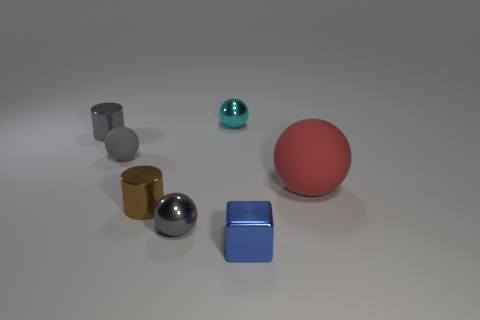Subtract all tiny spheres. How many spheres are left? 1 Subtract all cyan spheres. How many spheres are left? 3 Subtract all brown spheres. Subtract all green blocks. How many spheres are left? 4 Add 2 tiny metal cylinders. How many objects exist? 9 Subtract all blocks. How many objects are left? 6 Subtract 0 gray blocks. How many objects are left? 7 Subtract all big red cylinders. Subtract all tiny cyan balls. How many objects are left? 6 Add 6 gray shiny objects. How many gray shiny objects are left? 8 Add 7 tiny blue shiny objects. How many tiny blue shiny objects exist? 8 